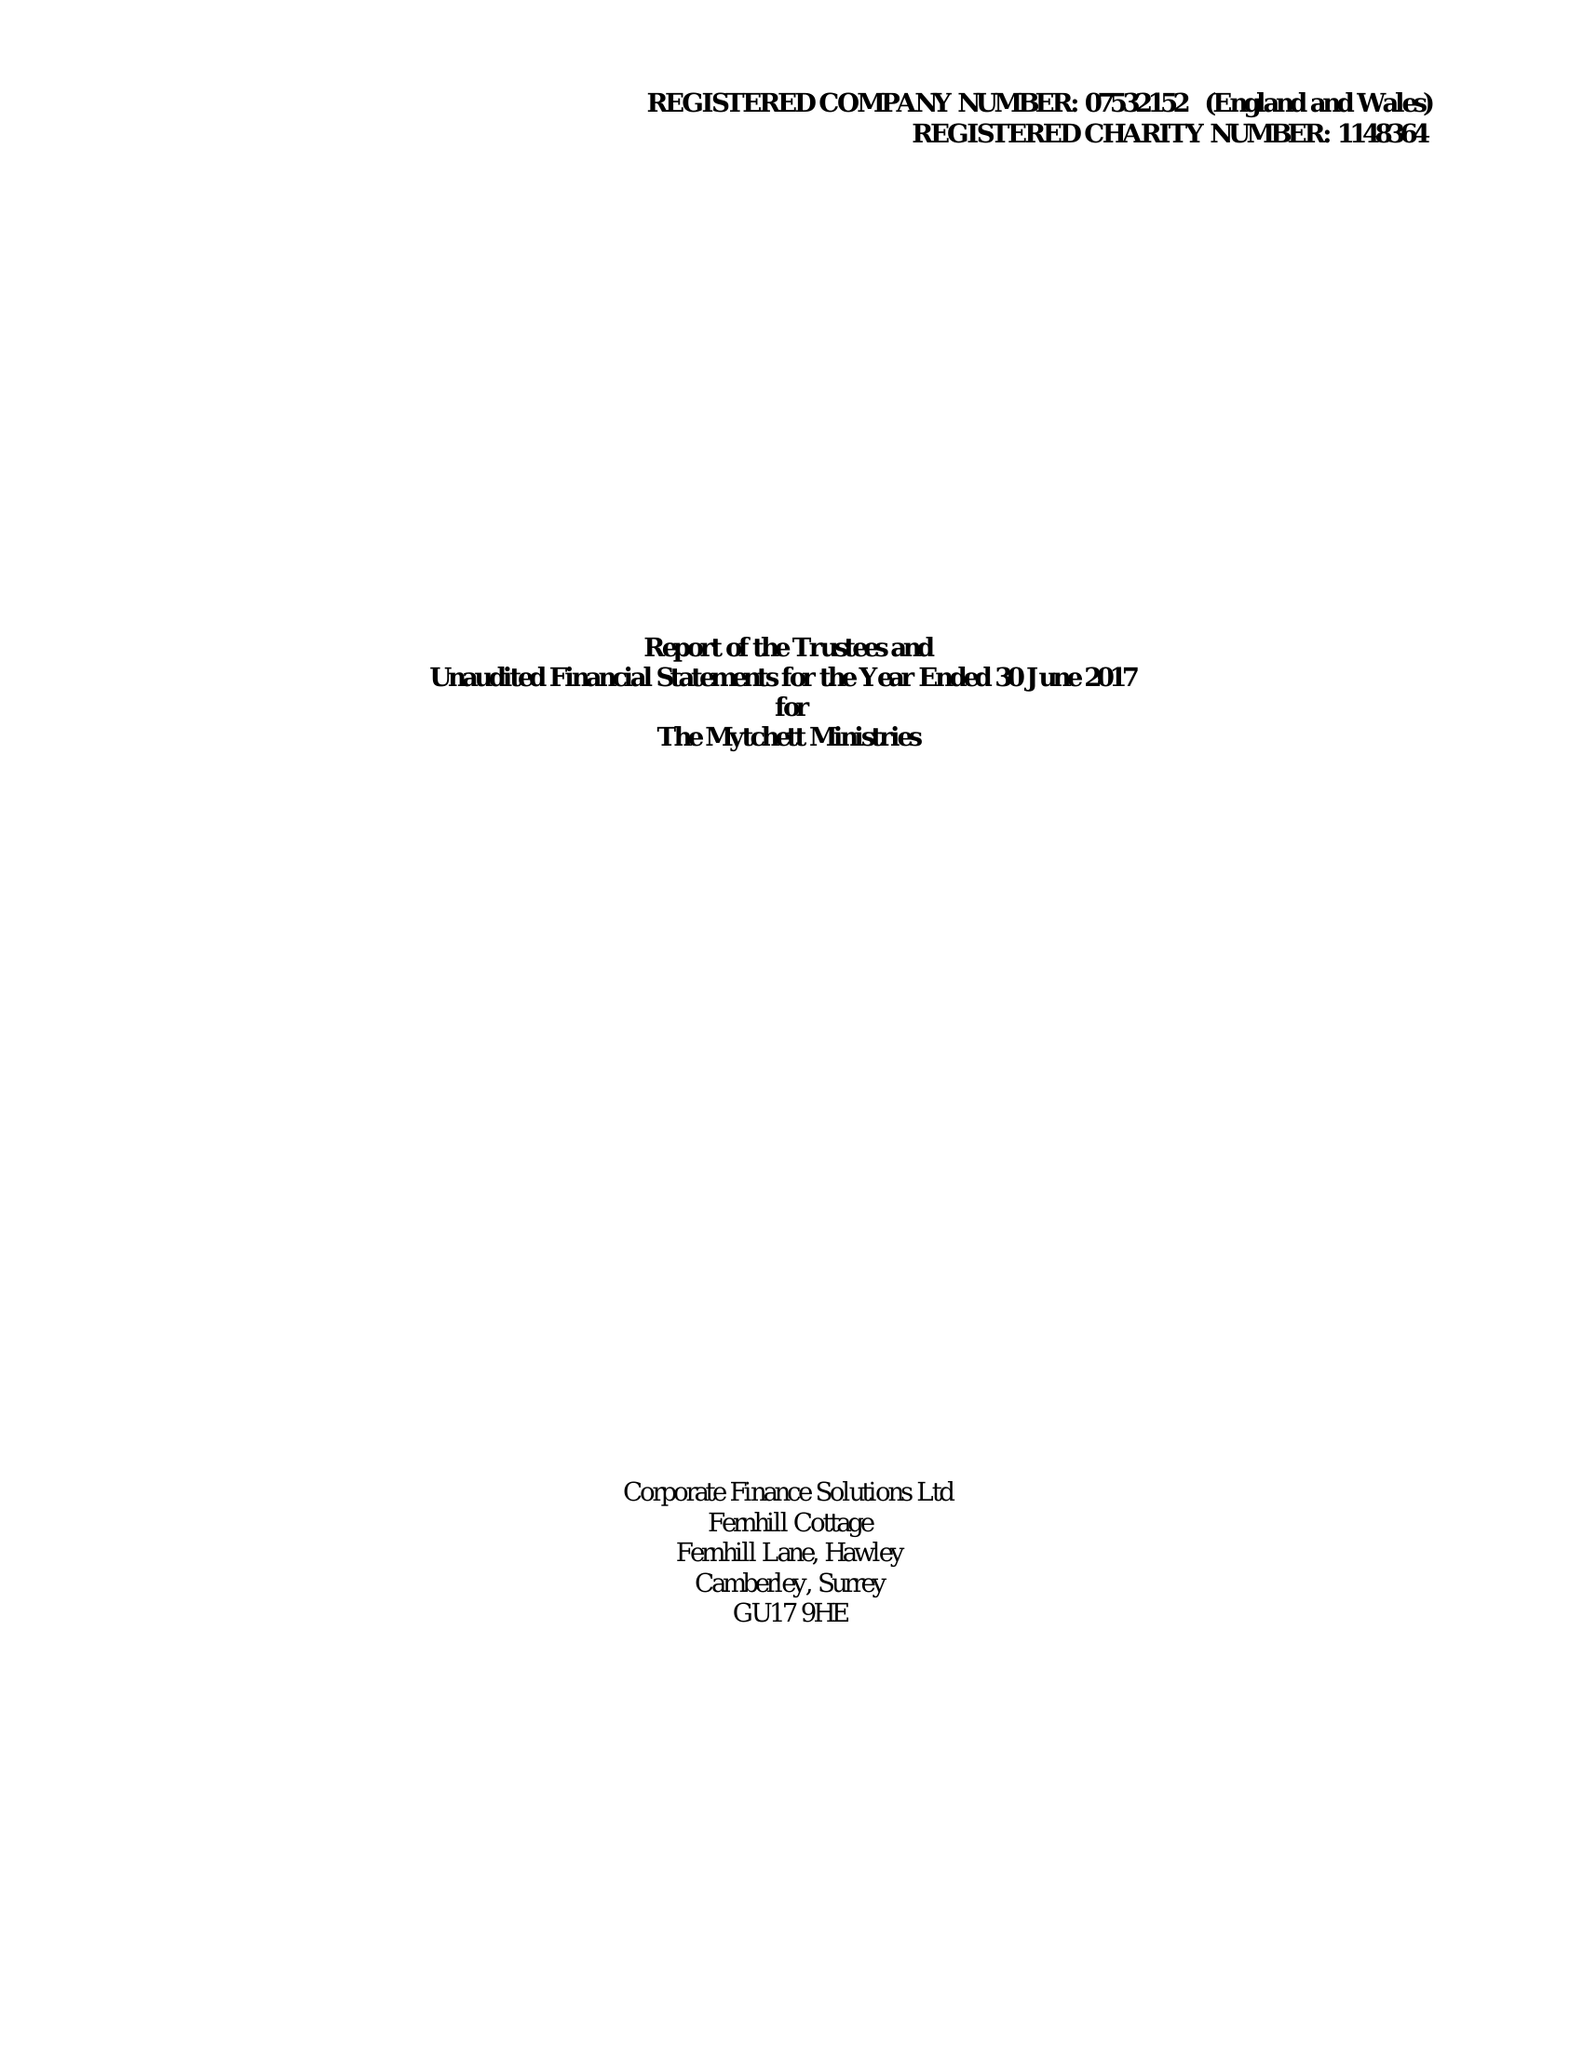What is the value for the charity_number?
Answer the question using a single word or phrase. 1148364 